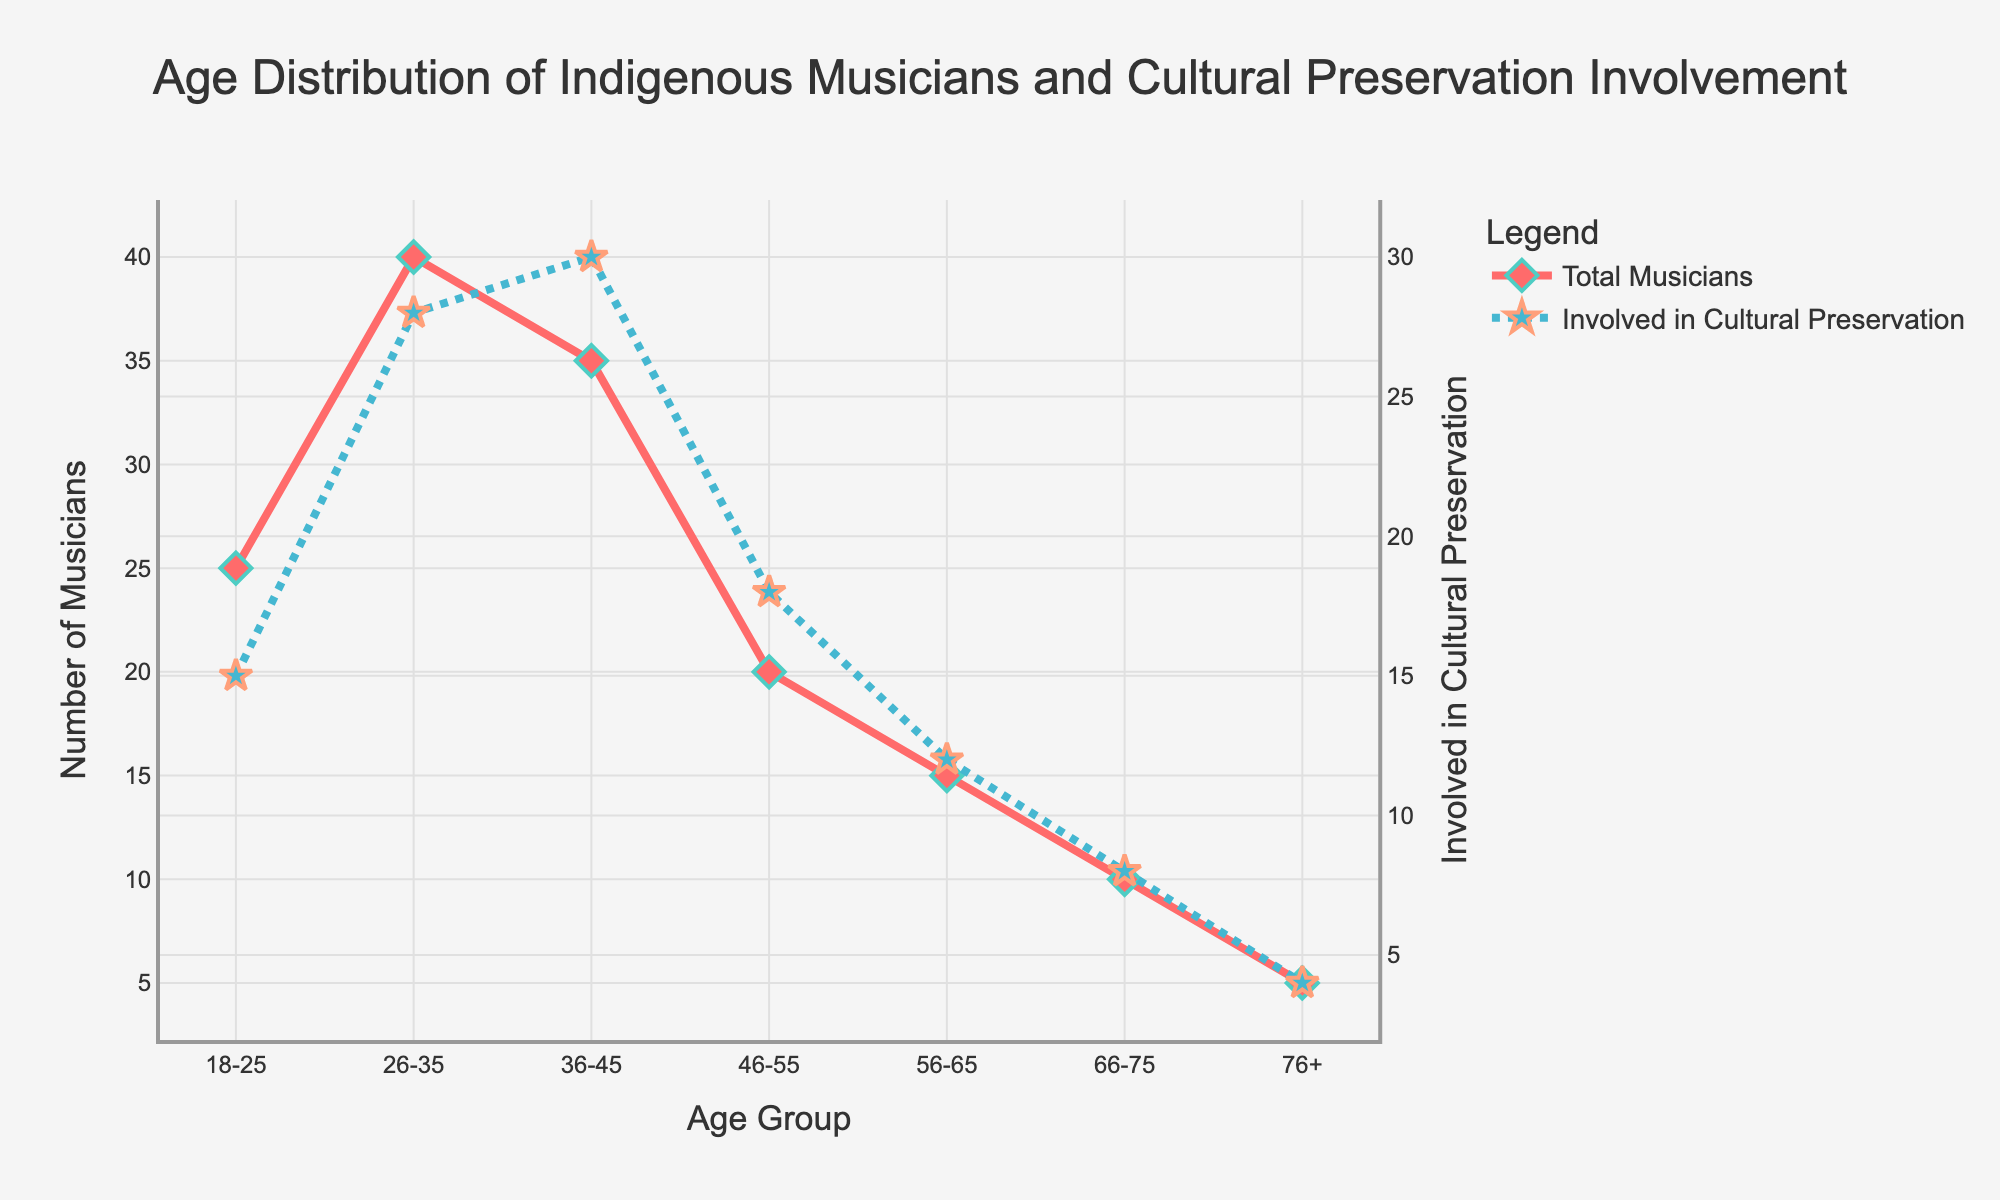What's the title of the plot? The plot's title is displayed at the top and provides a summary of the data being visualized.
Answer: Age Distribution of Indigenous Musicians and Cultural Preservation Involvement Which age group has the highest number of musicians? The age group with the peak in the 'Number of Musicians' plot indicates the group with the highest count.
Answer: 26-35 How many musicians are involved in cultural preservation in the 56-65 age group? By locating the age group 56-65 on the x-axis and following the corresponding value on the secondary y-axis (blue dotted line), we find the number involved in cultural preservation.
Answer: 12 What is the total number of musicians across all age groups? Sum up the 'Number_of_Musicians' values for all age groups: 25 + 40 + 35 + 20 + 15 + 10 + 5.
Answer: 150 Which age group has the fewest musicians involved in cultural preservation? Follow the lowest point on the secondary y-axis (blue dotted line) to determine the corresponding age group.
Answer: 76+ What is the difference between the number of musicians and the number of those involved in cultural preservation in the 36-45 age group? Subtract the number involved in cultural preservation from the total number of musicians for the 36-45 group: 35 - 30.
Answer: 5 Which age group has a higher number of musicians involved in cultural preservation, 46-55 or 18-25? Compare the y-axis values for 'Involved in Cultural Preservation' between these two age groups.
Answer: 46-55 How does the number of musicians involved in cultural preservation change from the 18-25 age group to the 26-35 age group? Observe the y-axis values for the 'Involved in Cultural Preservation' line between these two groups to note the difference. 15 to 28.
Answer: It increases What is the combined number of musicians involved in cultural preservation for the age groups 46-55 and 66-75? Add the 'Involved_in_Cultural_Preservation' values for these two age groups: 18 + 8.
Answer: 26 